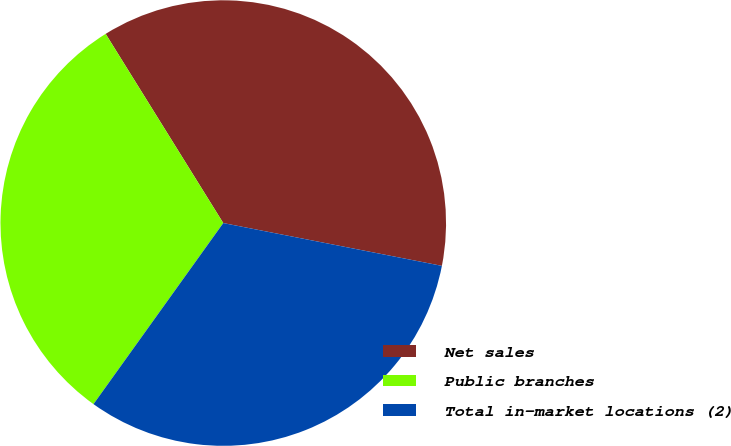<chart> <loc_0><loc_0><loc_500><loc_500><pie_chart><fcel>Net sales<fcel>Public branches<fcel>Total in-market locations (2)<nl><fcel>36.93%<fcel>31.25%<fcel>31.82%<nl></chart> 